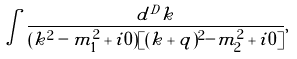<formula> <loc_0><loc_0><loc_500><loc_500>\int \frac { d ^ { D } k } { ( k ^ { 2 } - m _ { 1 } ^ { 2 } + i 0 ) [ ( k + q ) ^ { 2 } - m _ { 2 } ^ { 2 } + i 0 ] } ,</formula> 